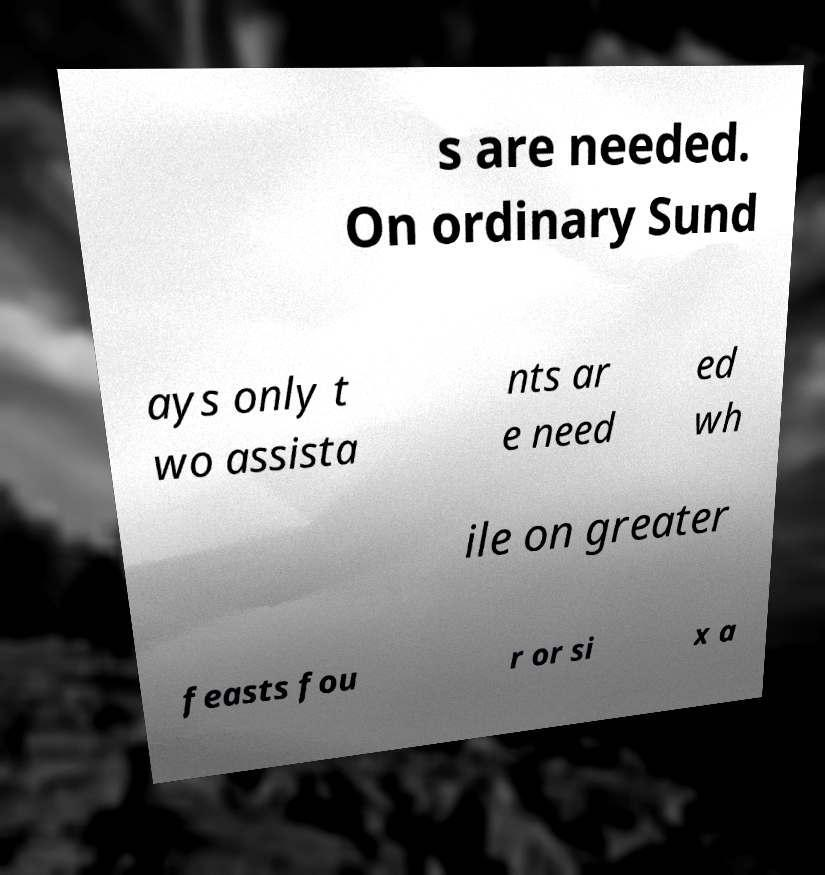For documentation purposes, I need the text within this image transcribed. Could you provide that? s are needed. On ordinary Sund ays only t wo assista nts ar e need ed wh ile on greater feasts fou r or si x a 